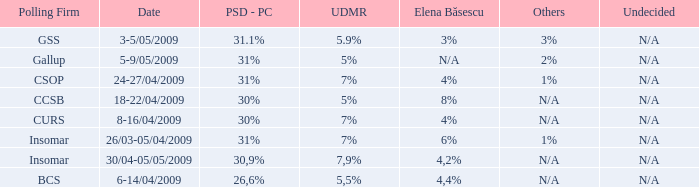What was the polling firm with others of 1%? Insomar, CSOP. 